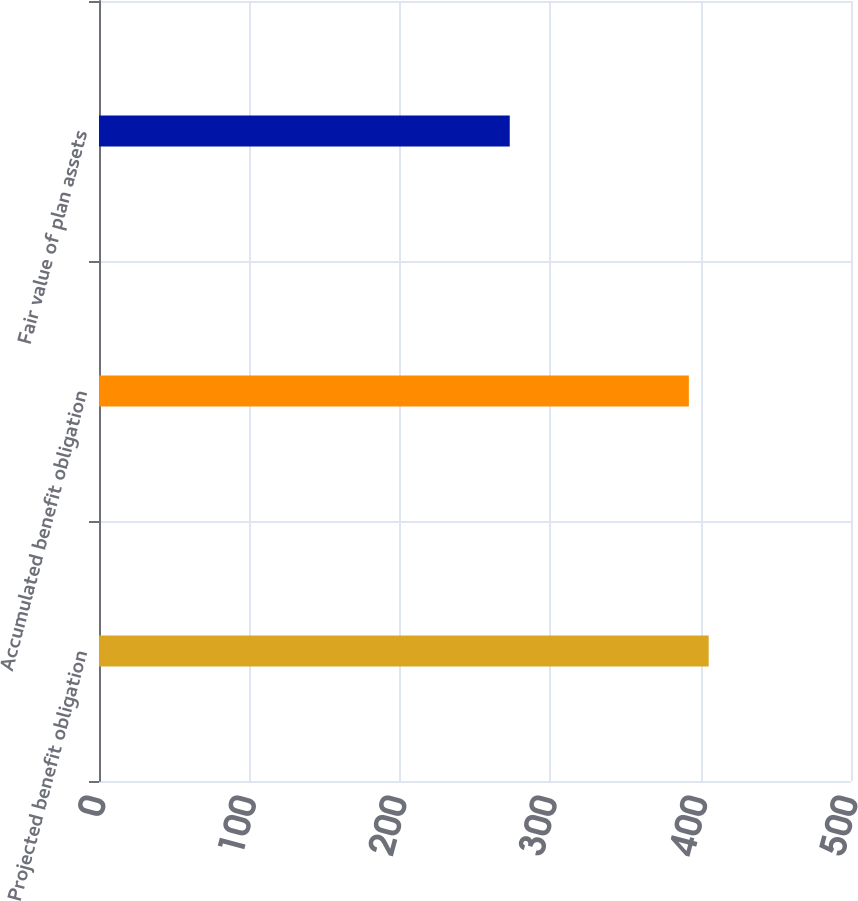Convert chart to OTSL. <chart><loc_0><loc_0><loc_500><loc_500><bar_chart><fcel>Projected benefit obligation<fcel>Accumulated benefit obligation<fcel>Fair value of plan assets<nl><fcel>405.38<fcel>392.2<fcel>273.1<nl></chart> 